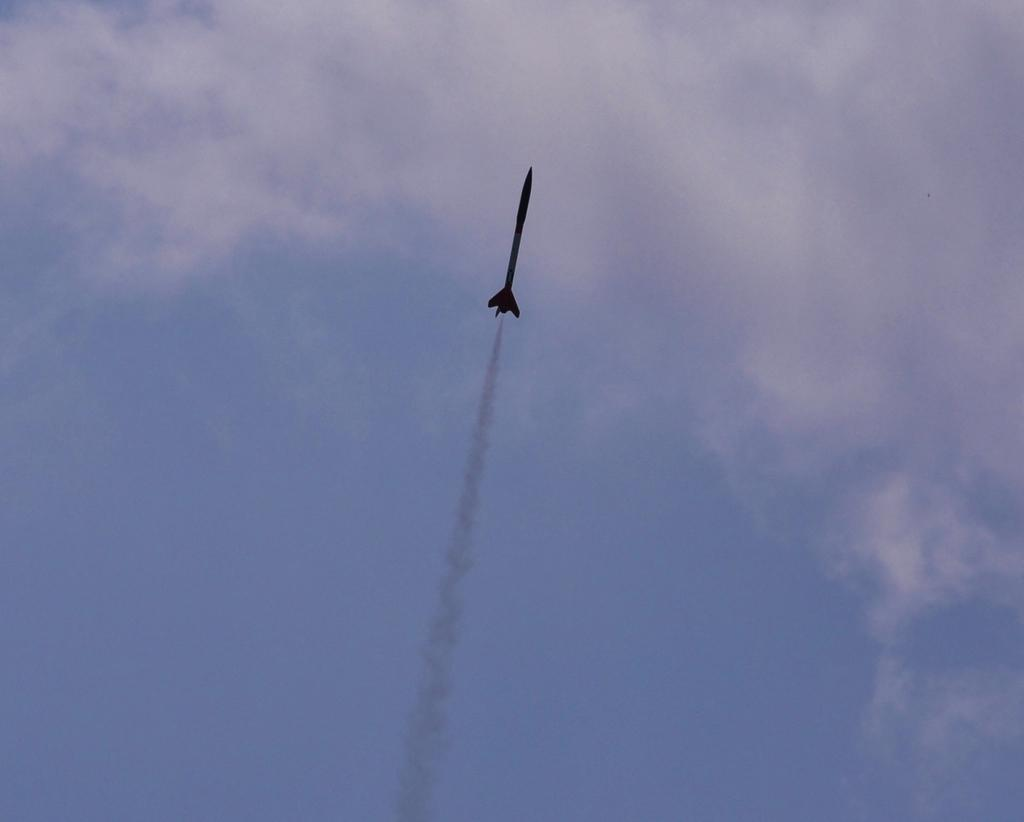What is the main subject of the image? The main subject of the image is a missile. What can be seen around the missile in the image? There is smoke in the image. What is visible in the background of the image? The sky is visible in the background of the image. How would you describe the weather based on the sky in the image? The sky appears to be clear in the background, suggesting good weather. What type of rhythm can be heard coming from the missile in the image? There is no sound or rhythm associated with the missile in the image; it is a static object. 